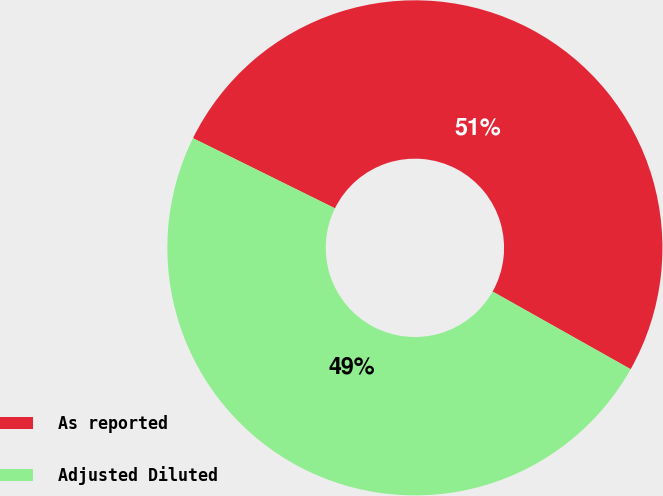Convert chart to OTSL. <chart><loc_0><loc_0><loc_500><loc_500><pie_chart><fcel>As reported<fcel>Adjusted Diluted<nl><fcel>50.85%<fcel>49.15%<nl></chart> 